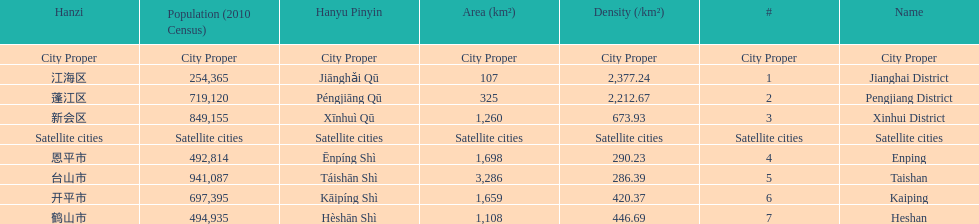What is the difference in population between enping and heshan? 2121. 